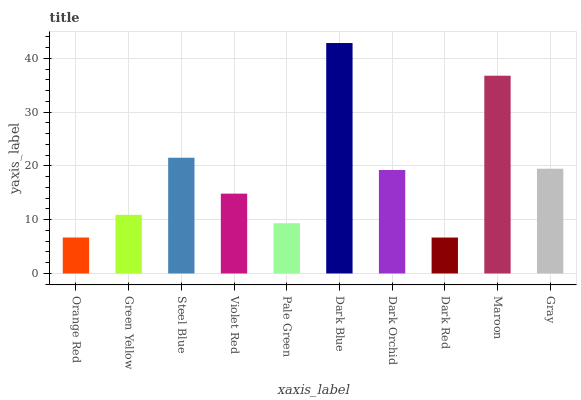Is Dark Red the minimum?
Answer yes or no. Yes. Is Dark Blue the maximum?
Answer yes or no. Yes. Is Green Yellow the minimum?
Answer yes or no. No. Is Green Yellow the maximum?
Answer yes or no. No. Is Green Yellow greater than Orange Red?
Answer yes or no. Yes. Is Orange Red less than Green Yellow?
Answer yes or no. Yes. Is Orange Red greater than Green Yellow?
Answer yes or no. No. Is Green Yellow less than Orange Red?
Answer yes or no. No. Is Dark Orchid the high median?
Answer yes or no. Yes. Is Violet Red the low median?
Answer yes or no. Yes. Is Green Yellow the high median?
Answer yes or no. No. Is Green Yellow the low median?
Answer yes or no. No. 